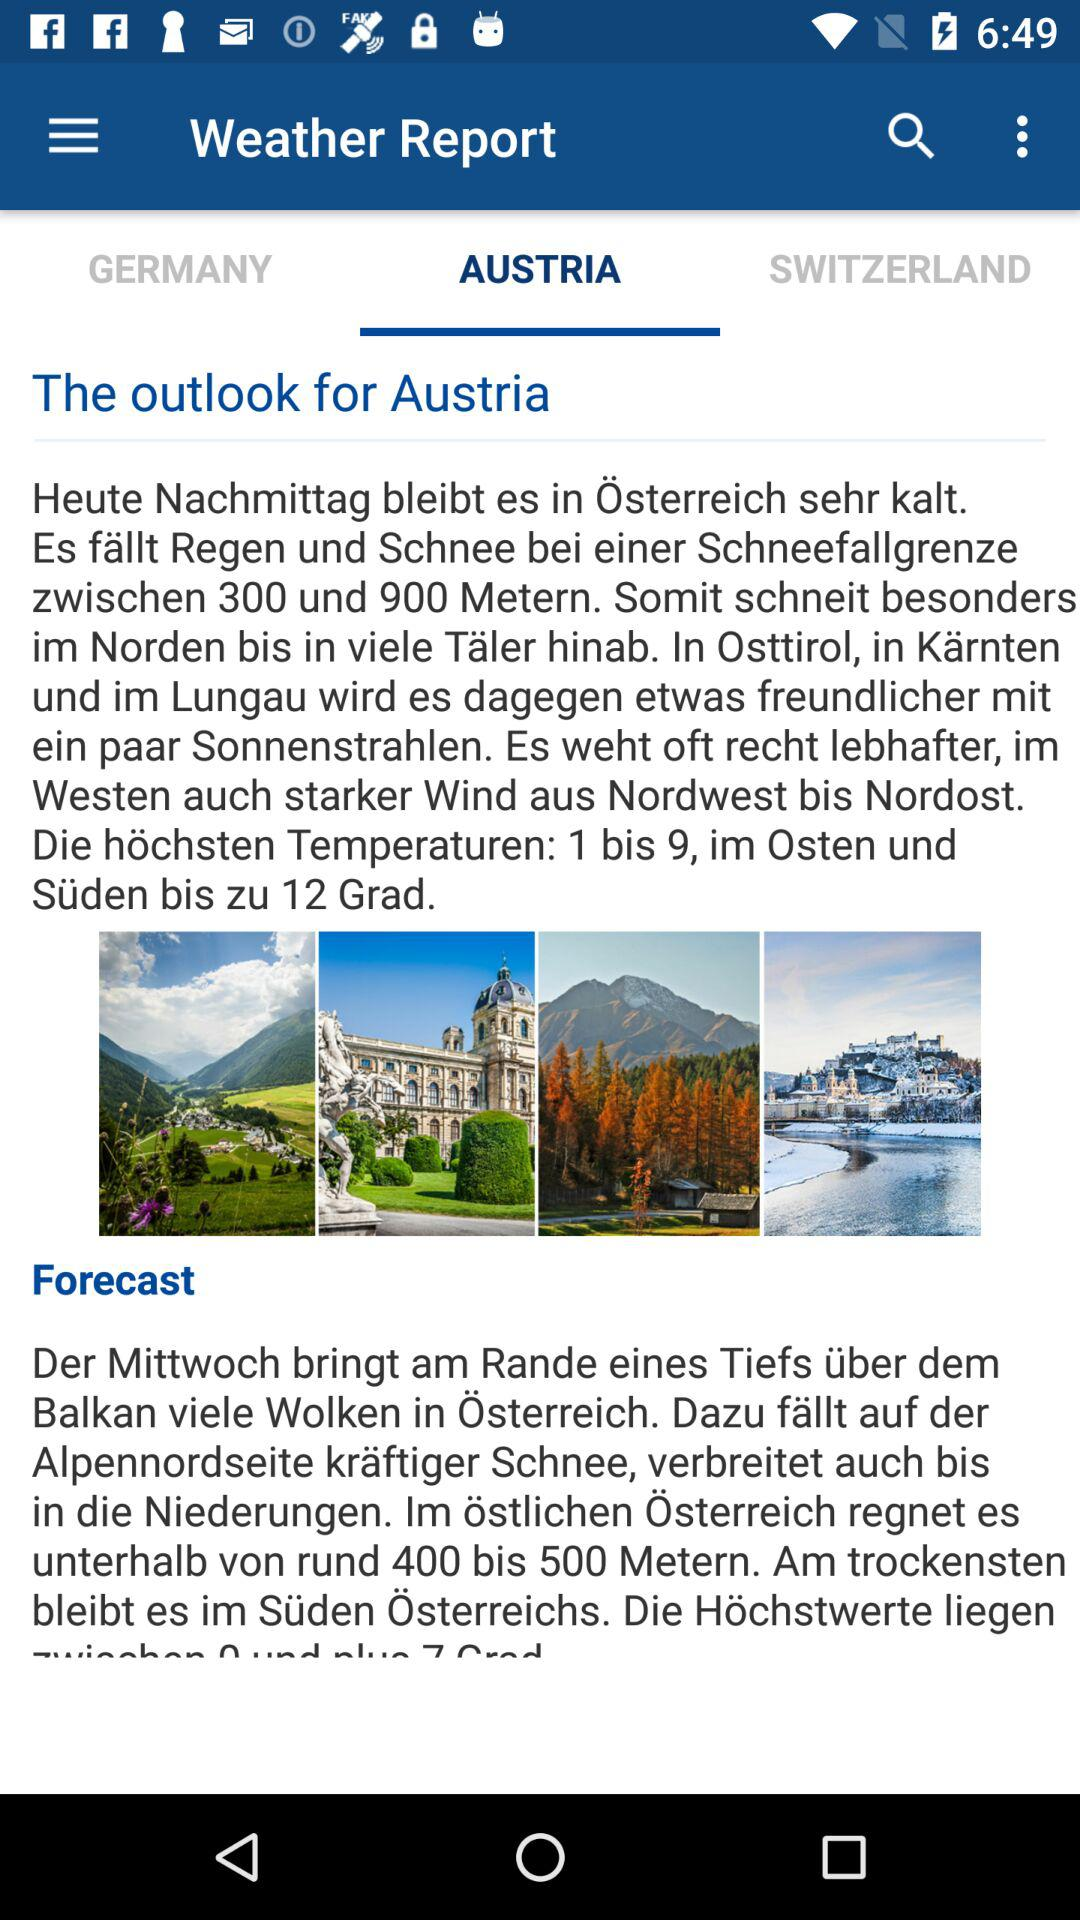Which country is selected in the "Weather Report"? The country that is selected in the "Weather Report" is Austria. 